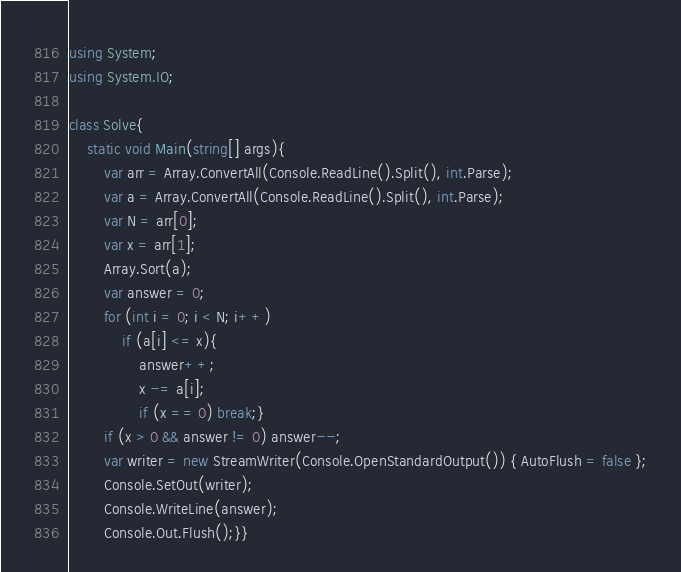Convert code to text. <code><loc_0><loc_0><loc_500><loc_500><_C#_>using System;
using System.IO;

class Solve{
    static void Main(string[] args){
        var arr = Array.ConvertAll(Console.ReadLine().Split(), int.Parse);
        var a = Array.ConvertAll(Console.ReadLine().Split(), int.Parse);
        var N = arr[0];
        var x = arr[1];
        Array.Sort(a);
        var answer = 0;
        for (int i = 0; i < N; i++)
            if (a[i] <= x){
                answer++;
                x -= a[i];
                if (x == 0) break;}
        if (x > 0 && answer != 0) answer--;
        var writer = new StreamWriter(Console.OpenStandardOutput()) { AutoFlush = false };
        Console.SetOut(writer);
        Console.WriteLine(answer);
        Console.Out.Flush();}}</code> 